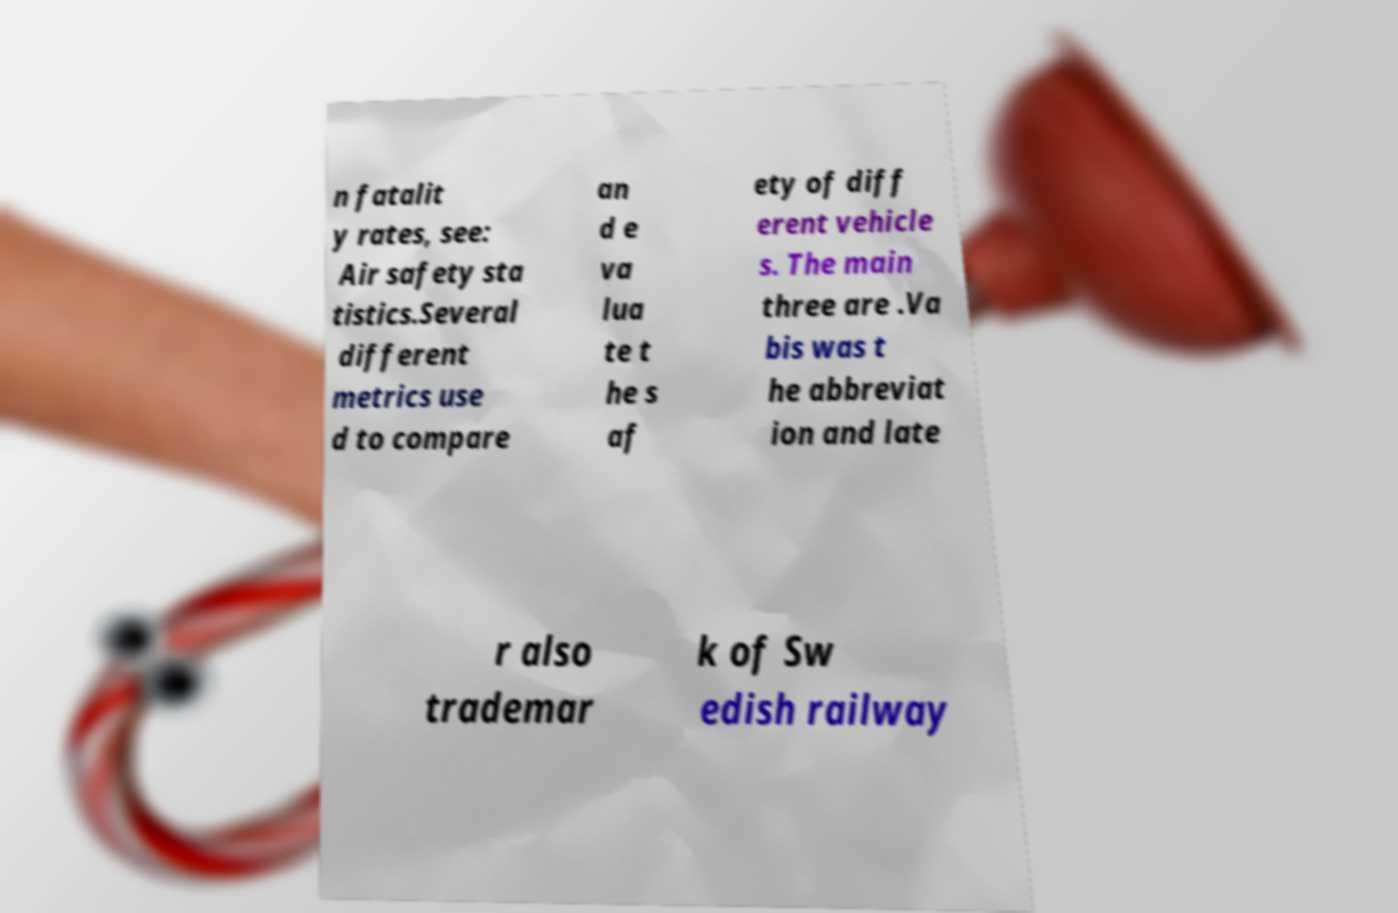Please identify and transcribe the text found in this image. n fatalit y rates, see: Air safety sta tistics.Several different metrics use d to compare an d e va lua te t he s af ety of diff erent vehicle s. The main three are .Va bis was t he abbreviat ion and late r also trademar k of Sw edish railway 